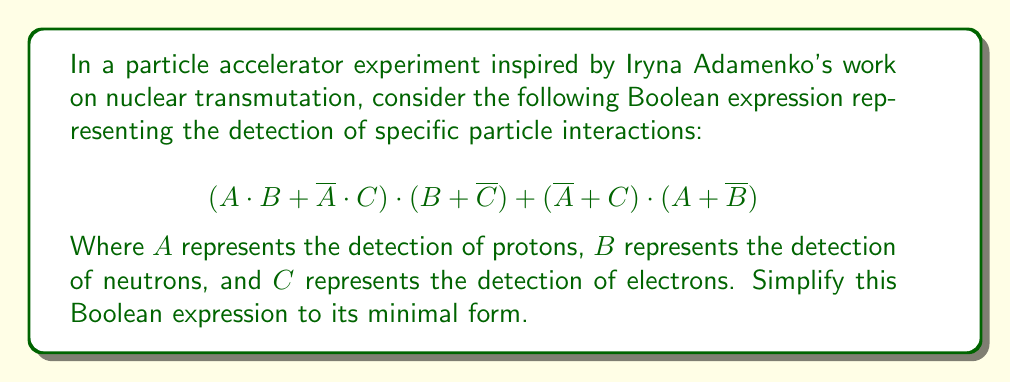Provide a solution to this math problem. Let's simplify this Boolean expression step by step:

1) First, let's distribute the terms in the first part:
   $$(A \cdot B + \overline{A} \cdot C) \cdot (B + \overline{C})$$
   $$= A \cdot B \cdot B + A \cdot B \cdot \overline{C} + \overline{A} \cdot C \cdot B + \overline{A} \cdot C \cdot \overline{C}$$

2) Simplify using the idempotent law $(B \cdot B = B)$ and the complement law $(C \cdot \overline{C} = 0)$:
   $$= A \cdot B + A \cdot B \cdot \overline{C} + \overline{A} \cdot C \cdot B + 0$$
   $$= A \cdot B + A \cdot B \cdot \overline{C} + \overline{A} \cdot C \cdot B$$

3) Now, let's distribute the terms in the second part:
   $$(\overline{A} + C) \cdot (A + \overline{B})$$
   $$= \overline{A} \cdot A + \overline{A} \cdot \overline{B} + C \cdot A + C \cdot \overline{B}$$

4) Simplify using the complement law $(\overline{A} \cdot A = 0)$:
   $$= 0 + \overline{A} \cdot \overline{B} + C \cdot A + C \cdot \overline{B}$$
   $$= \overline{A} \cdot \overline{B} + C \cdot A + C \cdot \overline{B}$$

5) Now, we have:
   $$(A \cdot B + A \cdot B \cdot \overline{C} + \overline{A} \cdot C \cdot B) + (\overline{A} \cdot \overline{B} + C \cdot A + C \cdot \overline{B})$$

6) Rearrange terms:
   $$A \cdot B + A \cdot B \cdot \overline{C} + \overline{A} \cdot C \cdot B + \overline{A} \cdot \overline{B} + C \cdot A + C \cdot \overline{B}$$

7) Use the absorption law to simplify $A \cdot B + A \cdot B \cdot \overline{C}$ to $A \cdot B$:
   $$A \cdot B + \overline{A} \cdot C \cdot B + \overline{A} \cdot \overline{B} + C \cdot A + C \cdot \overline{B}$$

8) Use the distributive law to factor out C:
   $$A \cdot B + \overline{A} \cdot \overline{B} + C \cdot (A + \overline{A} \cdot B + \overline{B})$$

9) Simplify $A + \overline{A} \cdot B + \overline{B}$ to 1 (this covers all possible combinations):
   $$A \cdot B + \overline{A} \cdot \overline{B} + C$$

This is the minimal form of the expression.
Answer: $$A \cdot B + \overline{A} \cdot \overline{B} + C$$ 